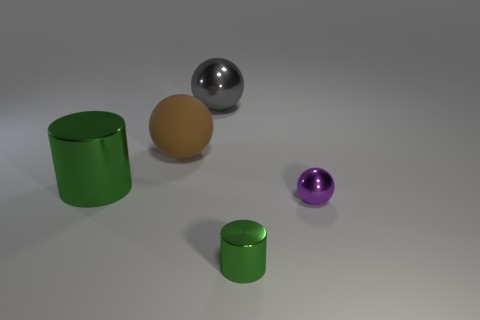What number of other objects are the same color as the large cylinder?
Give a very brief answer. 1. How many small green metal objects are the same shape as the large brown thing?
Keep it short and to the point. 0. Is the number of tiny balls behind the small metallic sphere the same as the number of green things that are left of the big cylinder?
Keep it short and to the point. Yes. Are there any tiny green things made of the same material as the large green thing?
Your response must be concise. Yes. Are the large gray object and the brown sphere made of the same material?
Offer a very short reply. No. How many brown things are matte objects or large metallic cylinders?
Keep it short and to the point. 1. Is the number of purple shiny balls that are to the left of the large gray ball greater than the number of large shiny cylinders?
Offer a terse response. No. Are there any small metallic spheres that have the same color as the big rubber object?
Keep it short and to the point. No. The gray metallic sphere is what size?
Your answer should be compact. Large. Do the tiny metal cylinder and the matte thing have the same color?
Give a very brief answer. No. 